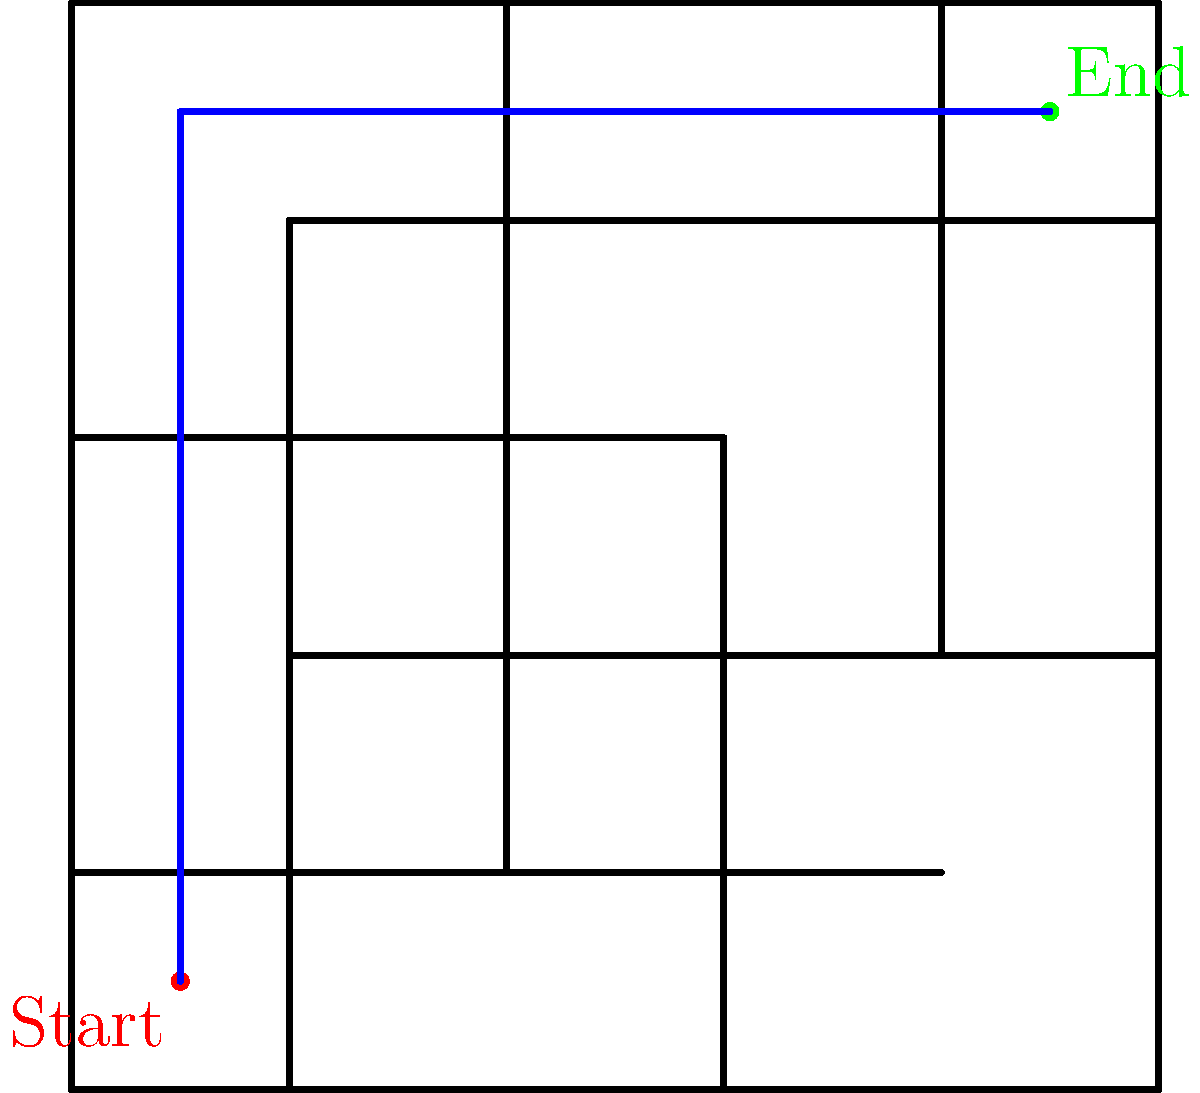As a criminal law expert, you're presented with a prison floor plan during a case involving a prison break. The layout is represented as a 10x10 grid maze. Given that each unit on the grid represents 5 meters, what is the shortest distance in meters from the marked start point (red) to the end point (green)? To solve this problem, we need to follow these steps:

1. Analyze the maze layout:
   The prison floor plan is presented as a 10x10 grid with walls creating a maze-like structure.

2. Identify the start and end points:
   - Start point (red): Bottom-left corner (1,1) in grid coordinates
   - End point (green): Top-right corner (9,9) in grid coordinates

3. Determine the shortest path:
   The shortest path is not always a straight line in a maze. In this case, the shortest path is:
   - Move vertically from (1,1) to (1,9)
   - Then move horizontally from (1,9) to (9,9)

4. Calculate the distance:
   - Vertical movement: 8 units
   - Horizontal movement: 8 units
   - Total movement: 8 + 8 = 16 units

5. Convert units to meters:
   Each unit represents 5 meters, so:
   $16 \times 5 = 80$ meters

Therefore, the shortest distance from the start point to the end point is 80 meters.
Answer: 80 meters 